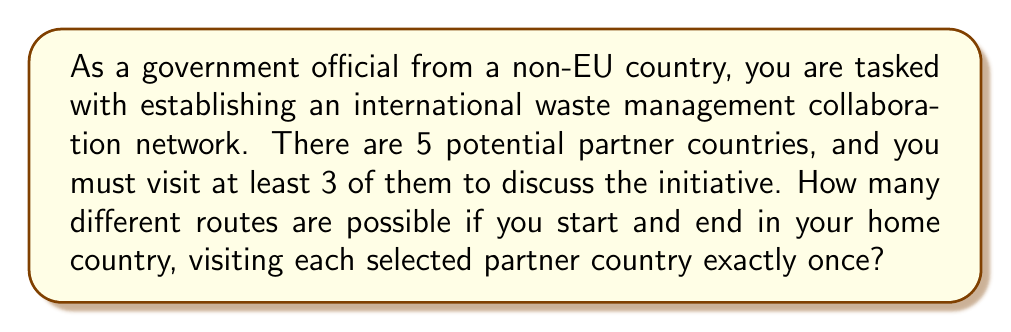Provide a solution to this math problem. Let's approach this step-by-step:

1) First, we need to choose which countries to visit. We can visit 3, 4, or 5 countries.

2) For each case, we'll use the combination formula to select countries, then multiply by the number of permutations to account for different orders:

   a) Visiting 3 countries:
      - Ways to choose 3 out of 5: $\binom{5}{3} = 10$
      - Permutations of 3: $3! = 6$
      - Total: $10 \times 6 = 60$

   b) Visiting 4 countries:
      - Ways to choose 4 out of 5: $\binom{5}{4} = 5$
      - Permutations of 4: $4! = 24$
      - Total: $5 \times 24 = 120$

   c) Visiting 5 countries:
      - Only 1 way to choose all 5
      - Permutations of 5: $5! = 120$
      - Total: $1 \times 120 = 120$

3) The total number of routes is the sum of all these possibilities:

   $$ \text{Total routes} = 60 + 120 + 120 = 300 $$

Therefore, there are 300 different possible routes for the international waste management collaboration network.
Answer: 300 routes 